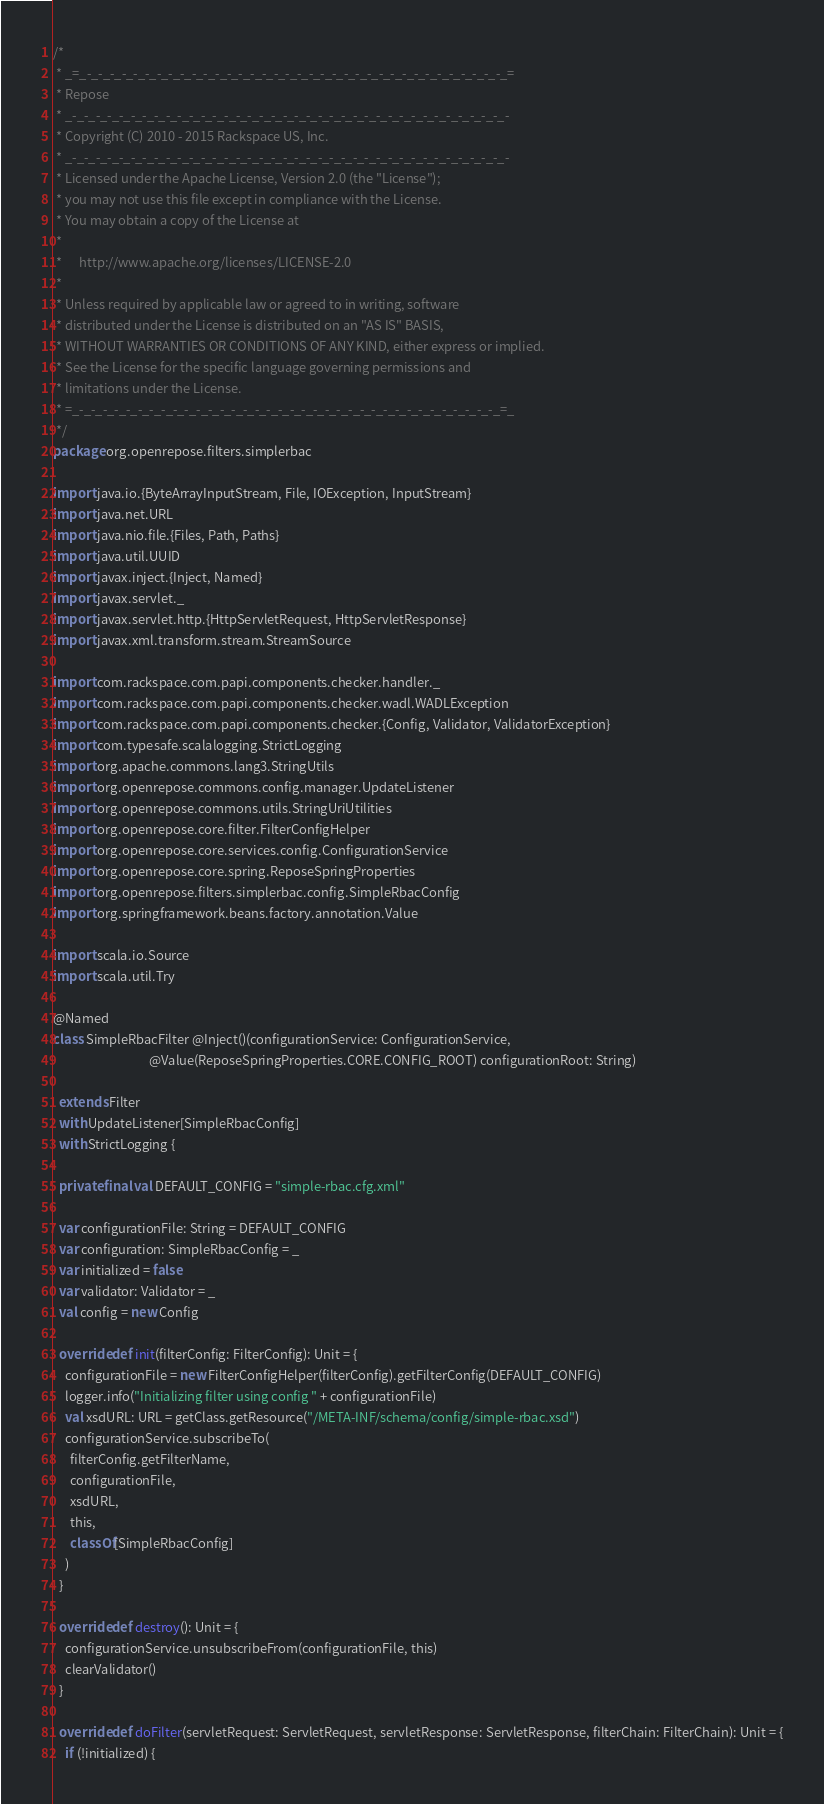Convert code to text. <code><loc_0><loc_0><loc_500><loc_500><_Scala_>/*
 * _=_-_-_-_-_-_-_-_-_-_-_-_-_-_-_-_-_-_-_-_-_-_-_-_-_-_-_-_-_-_-_-_-_-_-_-_-_=
 * Repose
 * _-_-_-_-_-_-_-_-_-_-_-_-_-_-_-_-_-_-_-_-_-_-_-_-_-_-_-_-_-_-_-_-_-_-_-_-_-_-
 * Copyright (C) 2010 - 2015 Rackspace US, Inc.
 * _-_-_-_-_-_-_-_-_-_-_-_-_-_-_-_-_-_-_-_-_-_-_-_-_-_-_-_-_-_-_-_-_-_-_-_-_-_-
 * Licensed under the Apache License, Version 2.0 (the "License");
 * you may not use this file except in compliance with the License.
 * You may obtain a copy of the License at
 *
 *      http://www.apache.org/licenses/LICENSE-2.0
 *
 * Unless required by applicable law or agreed to in writing, software
 * distributed under the License is distributed on an "AS IS" BASIS,
 * WITHOUT WARRANTIES OR CONDITIONS OF ANY KIND, either express or implied.
 * See the License for the specific language governing permissions and
 * limitations under the License.
 * =_-_-_-_-_-_-_-_-_-_-_-_-_-_-_-_-_-_-_-_-_-_-_-_-_-_-_-_-_-_-_-_-_-_-_-_-_=_
 */
package org.openrepose.filters.simplerbac

import java.io.{ByteArrayInputStream, File, IOException, InputStream}
import java.net.URL
import java.nio.file.{Files, Path, Paths}
import java.util.UUID
import javax.inject.{Inject, Named}
import javax.servlet._
import javax.servlet.http.{HttpServletRequest, HttpServletResponse}
import javax.xml.transform.stream.StreamSource

import com.rackspace.com.papi.components.checker.handler._
import com.rackspace.com.papi.components.checker.wadl.WADLException
import com.rackspace.com.papi.components.checker.{Config, Validator, ValidatorException}
import com.typesafe.scalalogging.StrictLogging
import org.apache.commons.lang3.StringUtils
import org.openrepose.commons.config.manager.UpdateListener
import org.openrepose.commons.utils.StringUriUtilities
import org.openrepose.core.filter.FilterConfigHelper
import org.openrepose.core.services.config.ConfigurationService
import org.openrepose.core.spring.ReposeSpringProperties
import org.openrepose.filters.simplerbac.config.SimpleRbacConfig
import org.springframework.beans.factory.annotation.Value

import scala.io.Source
import scala.util.Try

@Named
class SimpleRbacFilter @Inject()(configurationService: ConfigurationService,
                                 @Value(ReposeSpringProperties.CORE.CONFIG_ROOT) configurationRoot: String)

  extends Filter
  with UpdateListener[SimpleRbacConfig]
  with StrictLogging {

  private final val DEFAULT_CONFIG = "simple-rbac.cfg.xml"

  var configurationFile: String = DEFAULT_CONFIG
  var configuration: SimpleRbacConfig = _
  var initialized = false
  var validator: Validator = _
  val config = new Config

  override def init(filterConfig: FilterConfig): Unit = {
    configurationFile = new FilterConfigHelper(filterConfig).getFilterConfig(DEFAULT_CONFIG)
    logger.info("Initializing filter using config " + configurationFile)
    val xsdURL: URL = getClass.getResource("/META-INF/schema/config/simple-rbac.xsd")
    configurationService.subscribeTo(
      filterConfig.getFilterName,
      configurationFile,
      xsdURL,
      this,
      classOf[SimpleRbacConfig]
    )
  }

  override def destroy(): Unit = {
    configurationService.unsubscribeFrom(configurationFile, this)
    clearValidator()
  }

  override def doFilter(servletRequest: ServletRequest, servletResponse: ServletResponse, filterChain: FilterChain): Unit = {
    if (!initialized) {</code> 